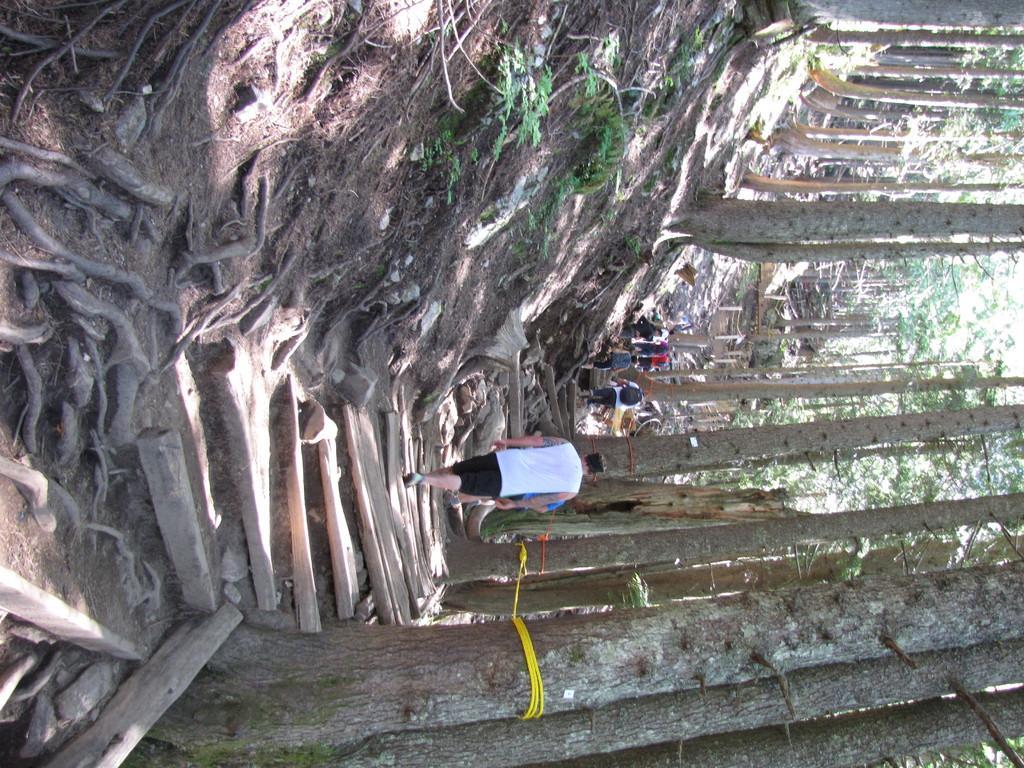Describe this image in one or two sentences. This picture is clicked outside. In the center we can see the group of persons walking on the ground and we can see the wooden objects. In the background we can see the trees and some other objects. 